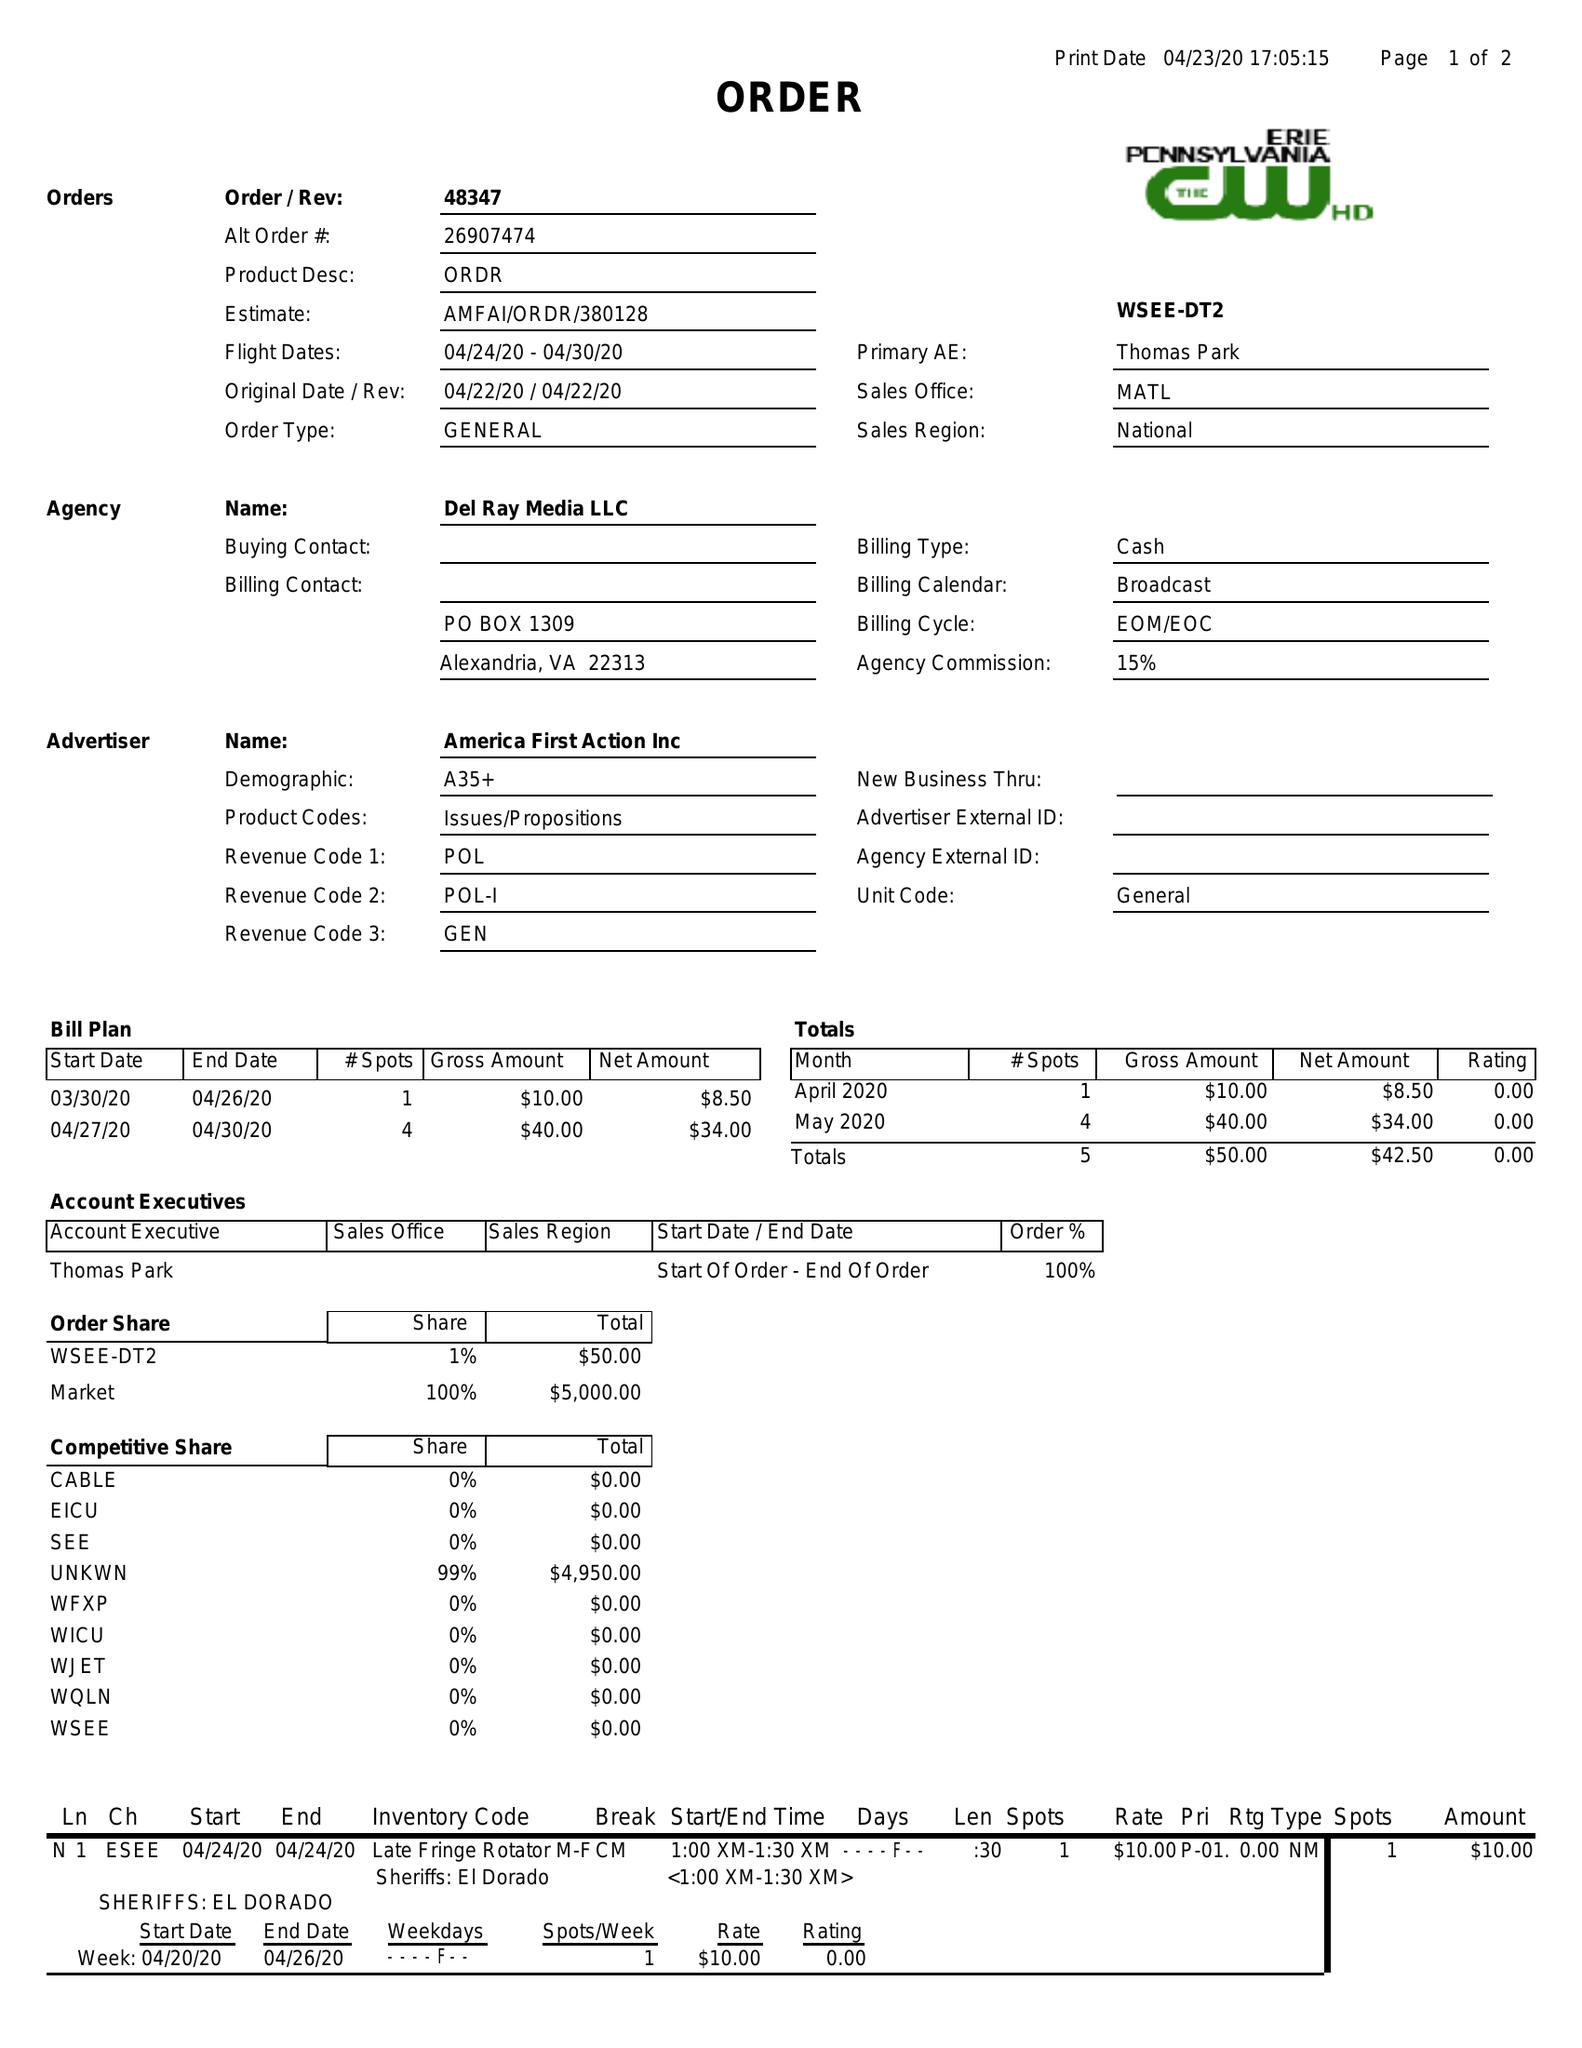What is the value for the gross_amount?
Answer the question using a single word or phrase. 50.00 